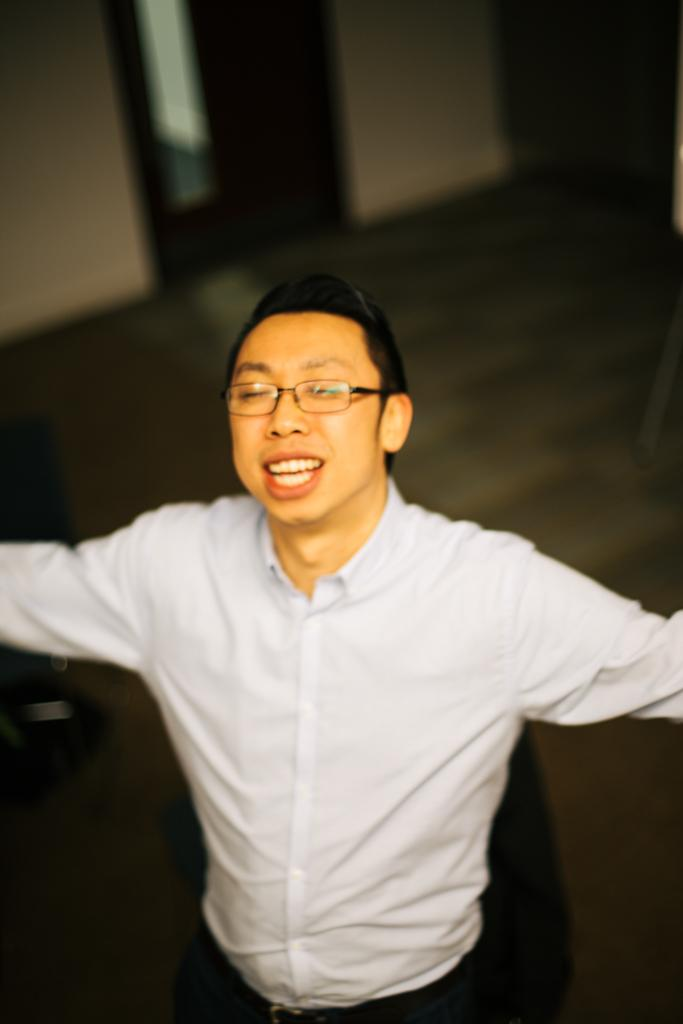Who is present in the image? There is a man in the image. What is the man wearing? The man is wearing a white shirt and spectacles. What can be seen in the background of the image? There is a wall in the background of the image. How many kittens are playing in the mist in the image? There are no kittens or mist present in the image; it features a man wearing a white shirt and spectacles with a wall in the background. 